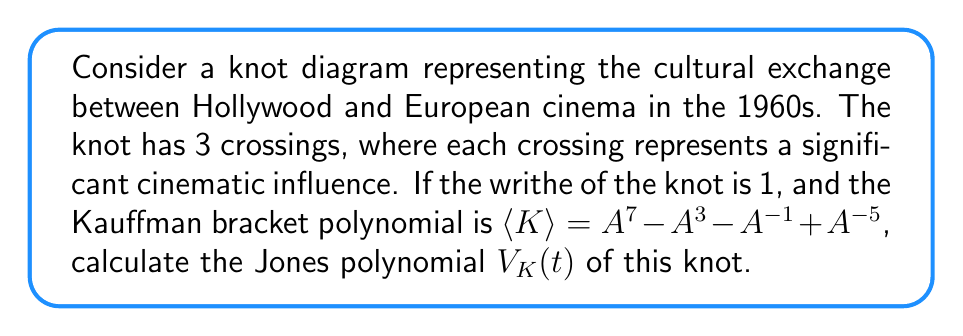Give your solution to this math problem. To find the Jones polynomial, we'll follow these steps:

1) Recall that the Jones polynomial is related to the Kauffman bracket polynomial by:
   $$V_K(t) = (-A^{-3})^{w(K)} \langle K \rangle |_{A = t^{-1/4}}$$
   where $w(K)$ is the writhe of the knot.

2) We're given that the writhe $w(K) = 1$ and 
   $$\langle K \rangle = A^7 - A^3 - A^{-1} + A^{-5}$$

3) Substituting these into the formula:
   $$V_K(t) = (-A^{-3})^1 (A^7 - A^3 - A^{-1} + A^{-5})|_{A = t^{-1/4}}$$

4) Simplify:
   $$V_K(t) = -A^{-3} (A^7 - A^3 - A^{-1} + A^{-5})|_{A = t^{-1/4}}$$
   $$V_K(t) = -(A^4 - 1 - A^{-4} + A^{-8})|_{A = t^{-1/4}}$$

5) Now substitute $A = t^{-1/4}$:
   $$V_K(t) = -(t^{-1} - 1 - t + t^2)$$

6) Multiply by -1:
   $$V_K(t) = t^{-1} - 1 - t + t^2$$

This is the Jones polynomial for the given knot.
Answer: $V_K(t) = t^{-1} - 1 - t + t^2$ 